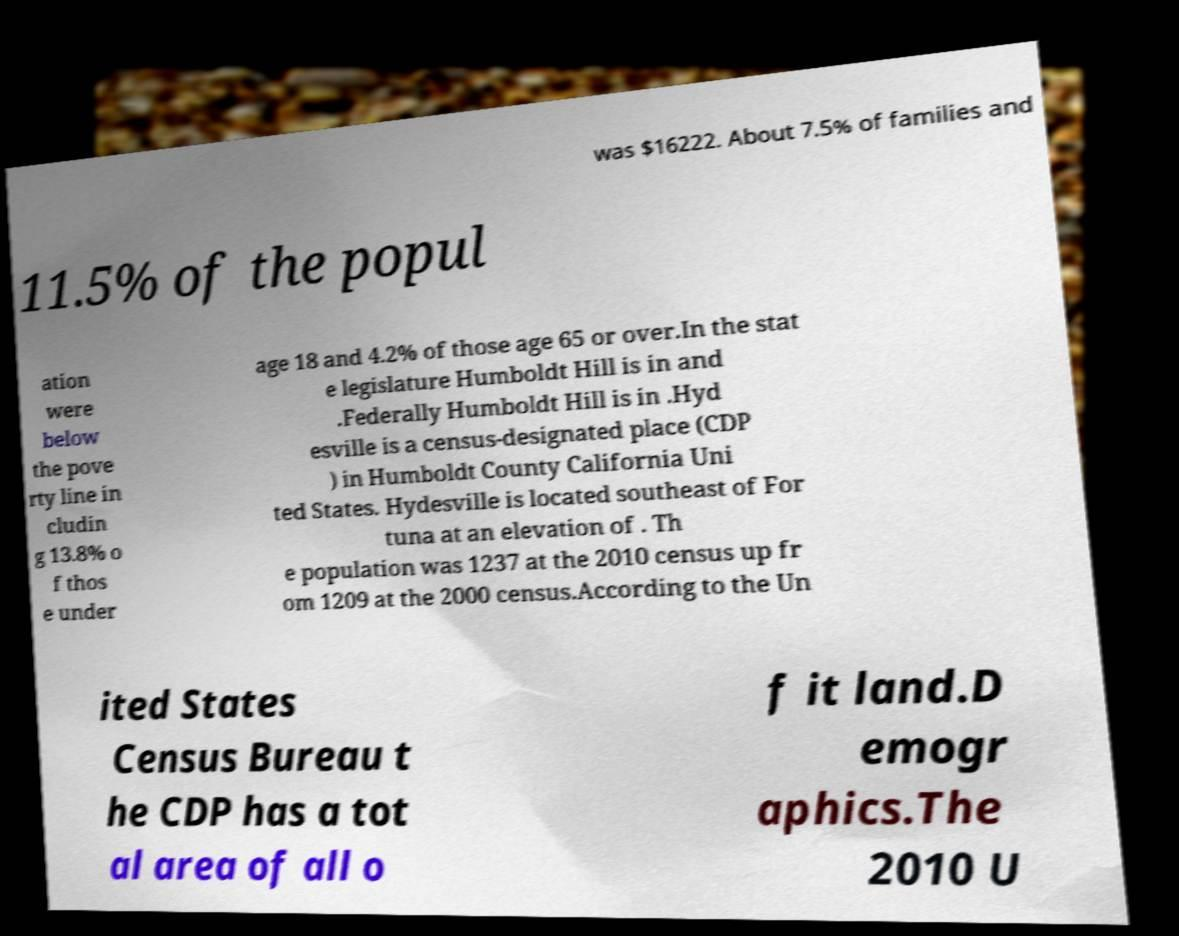Could you extract and type out the text from this image? was $16222. About 7.5% of families and 11.5% of the popul ation were below the pove rty line in cludin g 13.8% o f thos e under age 18 and 4.2% of those age 65 or over.In the stat e legislature Humboldt Hill is in and .Federally Humboldt Hill is in .Hyd esville is a census-designated place (CDP ) in Humboldt County California Uni ted States. Hydesville is located southeast of For tuna at an elevation of . Th e population was 1237 at the 2010 census up fr om 1209 at the 2000 census.According to the Un ited States Census Bureau t he CDP has a tot al area of all o f it land.D emogr aphics.The 2010 U 